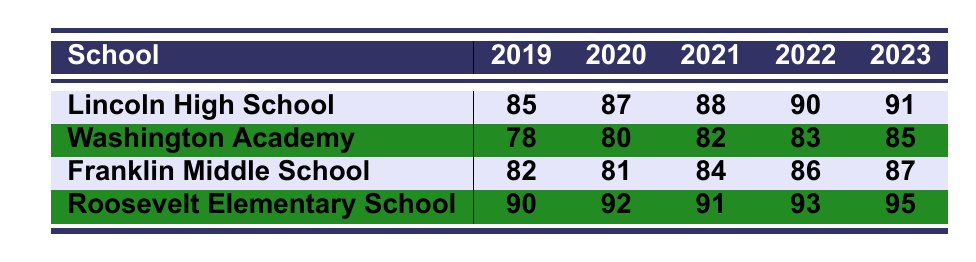What is the average test score of Lincoln High School in 2021? The table shows that Lincoln High School's average test score in 2021 is 88.
Answer: 88 What was the highest average test score recorded in 2023? The table lists the average test scores for 2023, with Roosevelt Elementary School having the highest score at 95.
Answer: 95 Which school had the lowest score in 2019? By comparing the average test scores for 2019, Washington Academy had the lowest score of 78.
Answer: 78 What is the average test score of Franklin Middle School over the five years? The scores for Franklin Middle School are 82, 81, 84, 86, and 87. Adding these gives 420, which divided by 5 equals 84.
Answer: 84 Did Washington Academy improve its average test score every year? Looking at the scores from 2019 to 2023, they increased each year: 78, 80, 82, 83, and 85, indicating a consistent improvement.
Answer: Yes What is the difference in average test scores between Roosevelt Elementary School and Franklin Middle School in 2022? In 2022, Roosevelt Elementary School scored 93 and Franklin Middle School scored 86. The difference is 93 - 86 = 7.
Answer: 7 Which school showed the most significant increase in average test scores from 2019 to 2023? Lincoln High School increased from 85 to 91, a difference of 6 points, while Roosevelt Elementary School increased from 90 to 95, also a 5-point difference. Therefore, Lincoln High School had the highest increase.
Answer: Lincoln High School What was the average test score for Washington Academy in 2022? The table indicates that Washington Academy's average test score for 2022 is 83.
Answer: 83 If we average the scores of all schools in 2023, what is the result? Adding the scores for 2023, which are 91 (Lincoln), 85 (Washington), 87 (Franklin), and 95 (Roosevelt) gives 358. Dividing 358 by 4 results in an average of 89.5.
Answer: 89.5 Is it true that Lincoln High School had a higher average test score than Franklin Middle School in every year? Comparing scores from 2019 to 2023, Lincoln High School scored higher than Franklin Middle School each year: 85 vs. 82, 87 vs. 81, 88 vs. 84, 90 vs. 86, and 91 vs. 87, which confirms that Lincoln scored higher in all years.
Answer: Yes 